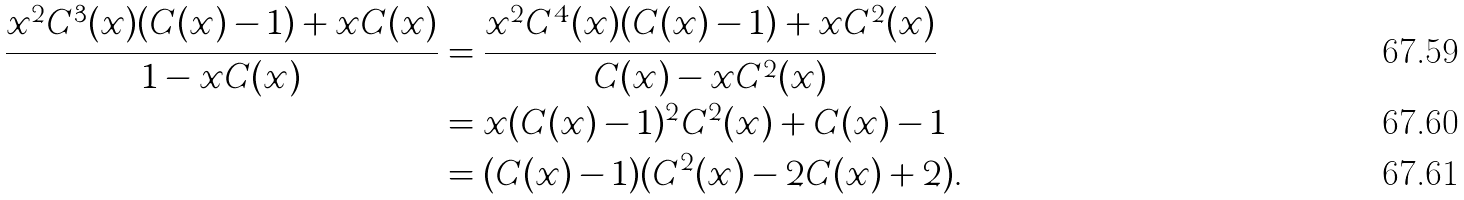Convert formula to latex. <formula><loc_0><loc_0><loc_500><loc_500>\frac { x ^ { 2 } C ^ { 3 } ( x ) ( C ( x ) - 1 ) + x C ( x ) } { 1 - x C ( x ) } & = \frac { x ^ { 2 } C ^ { 4 } ( x ) ( C ( x ) - 1 ) + x C ^ { 2 } ( x ) } { C ( x ) - x C ^ { 2 } ( x ) } \\ & = x ( C ( x ) - 1 ) ^ { 2 } C ^ { 2 } ( x ) + C ( x ) - 1 \\ & = ( C ( x ) - 1 ) ( C ^ { 2 } ( x ) - 2 C ( x ) + 2 ) .</formula> 